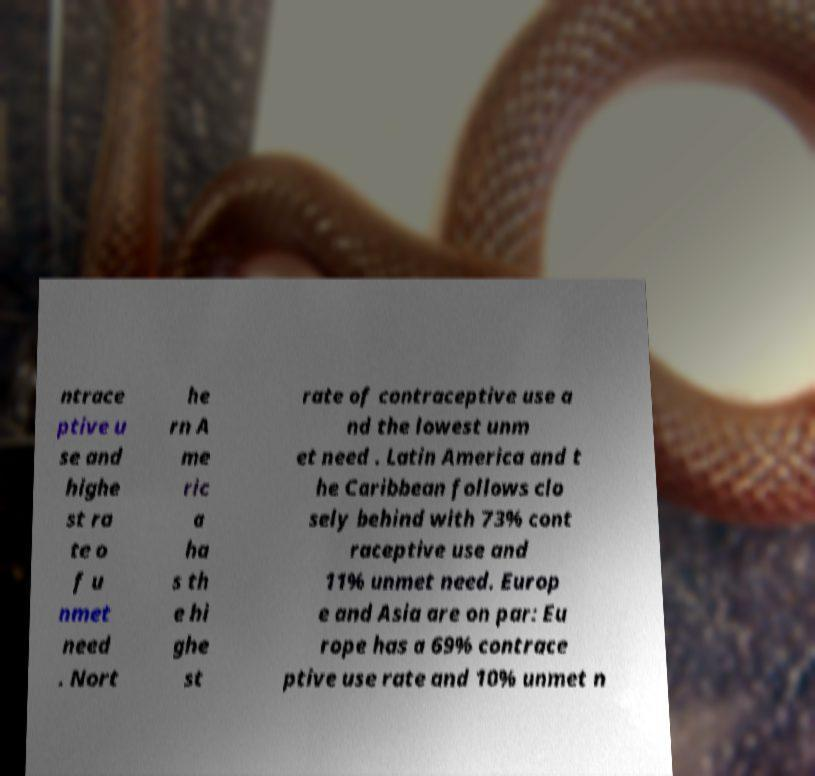Could you extract and type out the text from this image? ntrace ptive u se and highe st ra te o f u nmet need . Nort he rn A me ric a ha s th e hi ghe st rate of contraceptive use a nd the lowest unm et need . Latin America and t he Caribbean follows clo sely behind with 73% cont raceptive use and 11% unmet need. Europ e and Asia are on par: Eu rope has a 69% contrace ptive use rate and 10% unmet n 